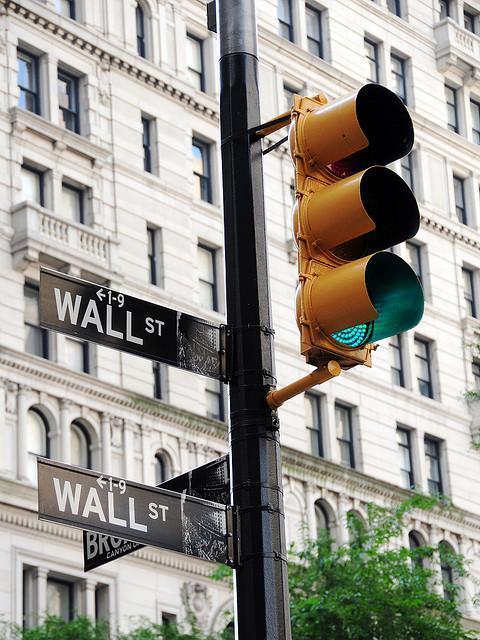How many people are in this photo?
Give a very brief answer. 0. 